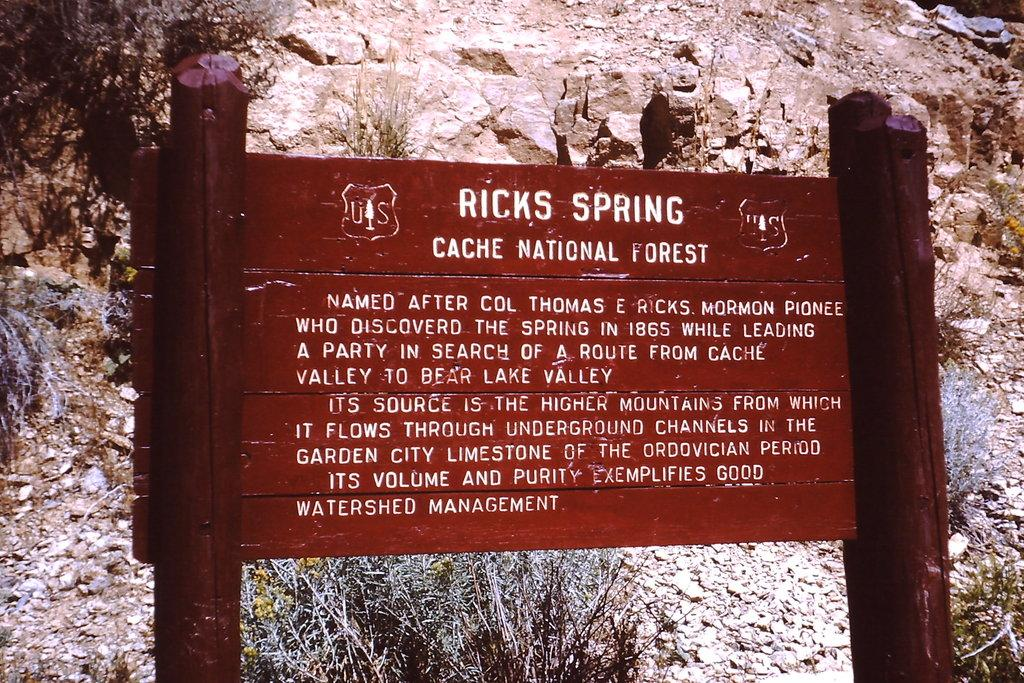What is the color and material of the board in the image? The board in the image is red and made of wood. What is written or drawn on the wooden board? There is script on the wooden board. What can be seen in the background of the image? There is a rock in the background of the image. What is present at the bottom of the image? There are stones and small plants at the bottom of the image. How many frogs are sitting in a circle on the wooden board? There are no frogs present in the image, and there is no circle on the wooden board. 